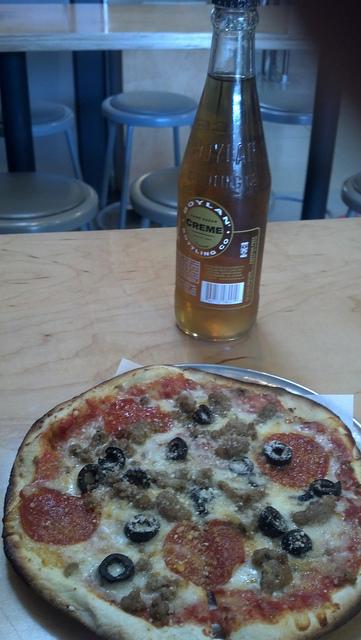How many people does the pizza feed?
Answer briefly. 1. What color is the table?
Give a very brief answer. Brown. What kind of drink is in the picture?
Short answer required. Beer. 